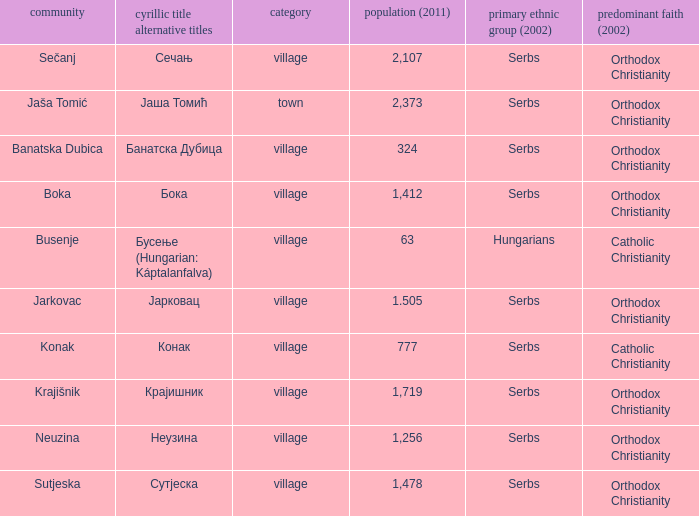What is the ethnic group is конак? Serbs. 